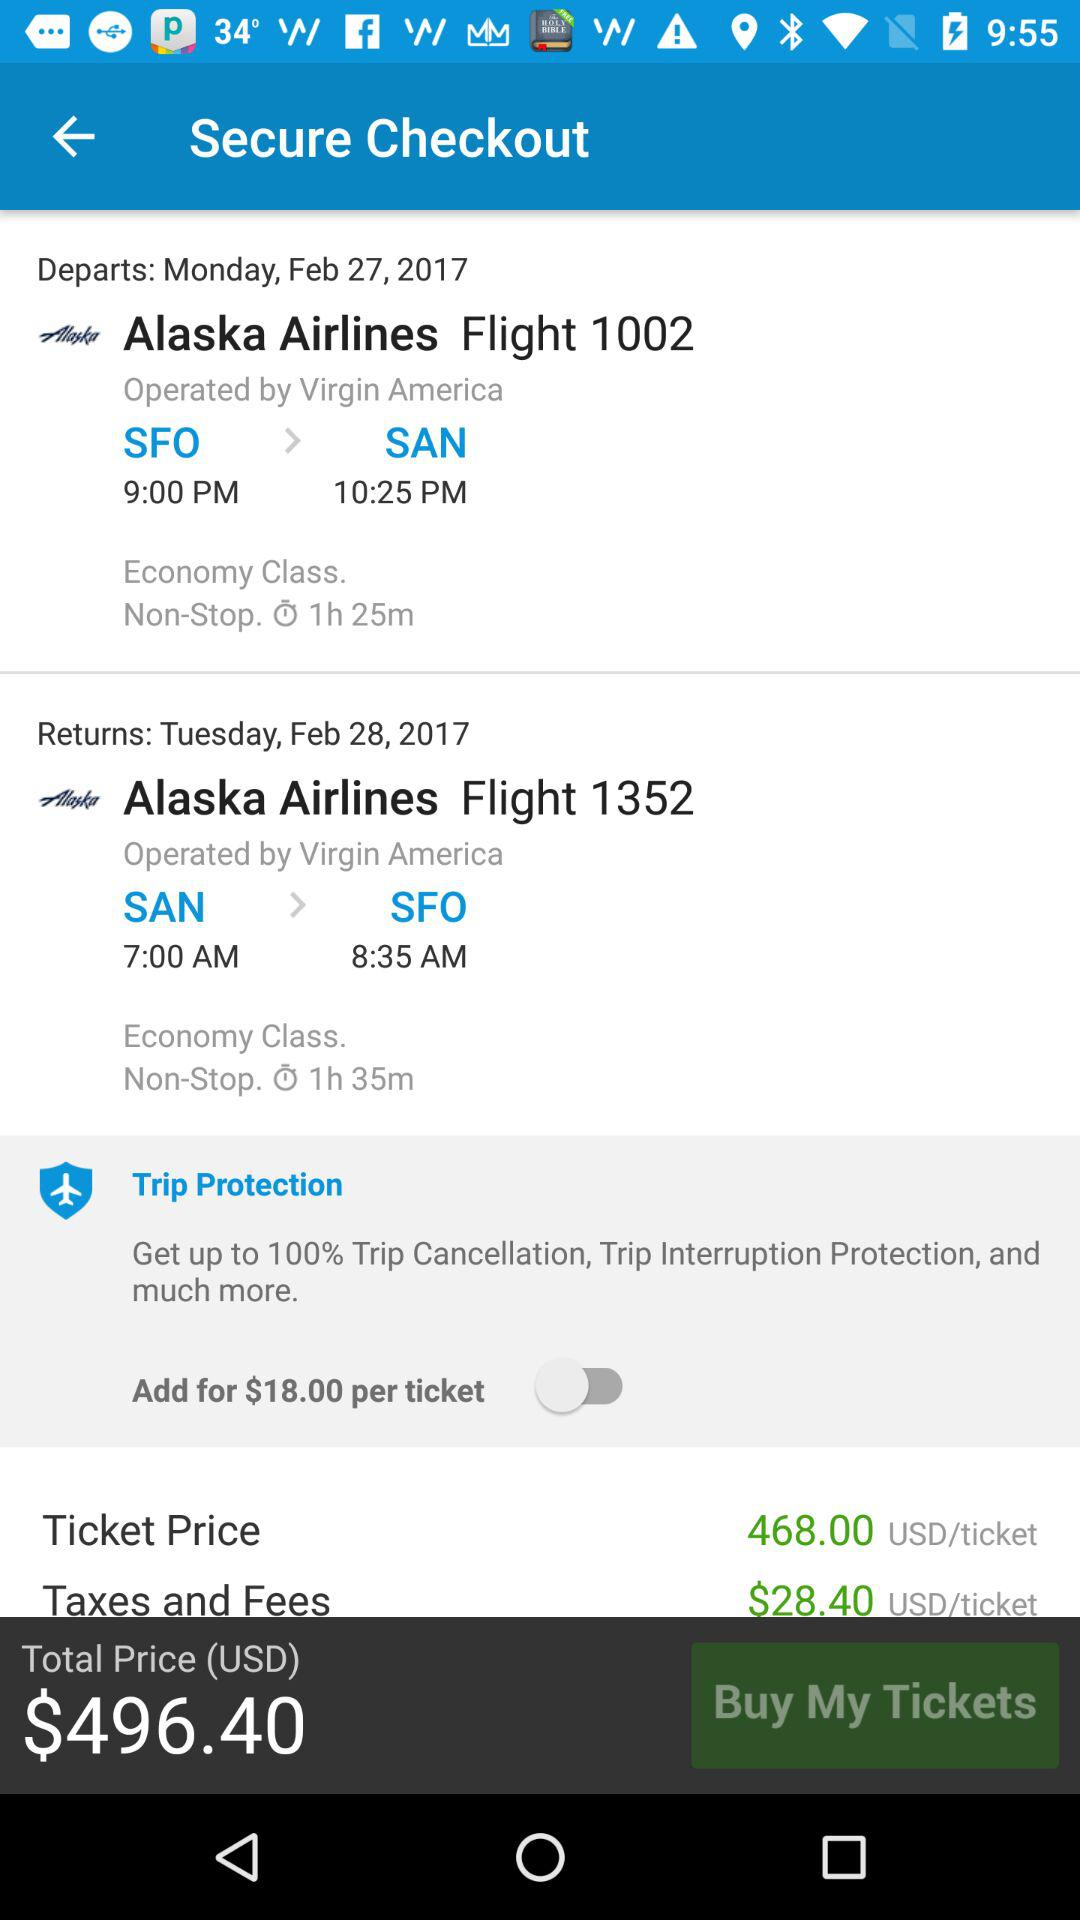What is the total price of the ticket?
Answer the question using a single word or phrase. $496.40 